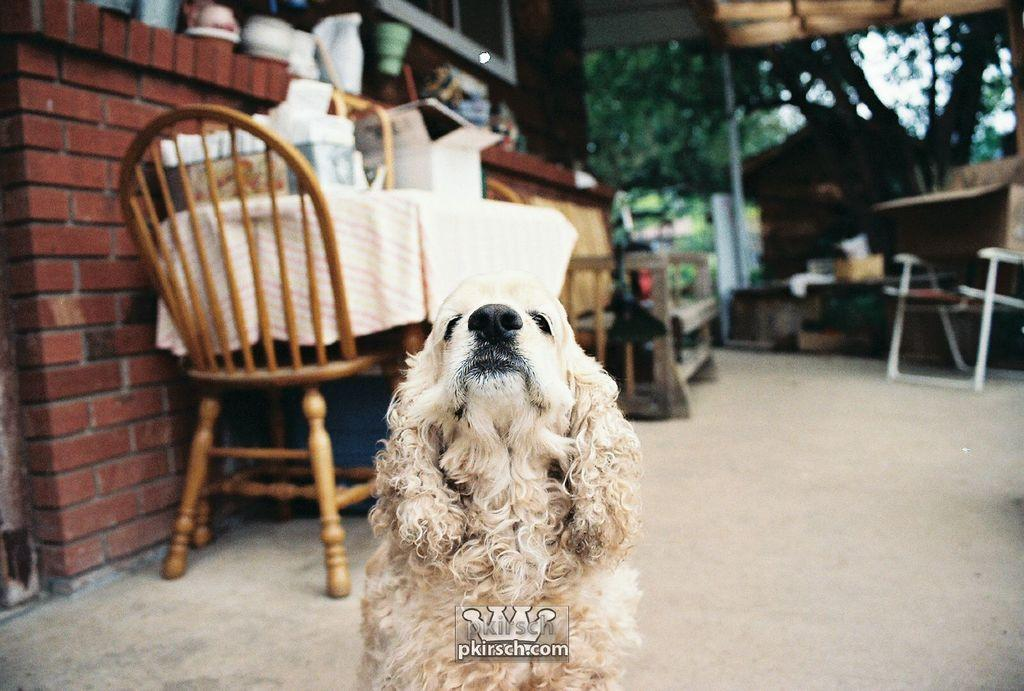What animal is on the floor in the image? There is a dog on the floor. What objects are behind the dog? There is a table and a chair behind the dog. What is on the table? There are two boxes on the table. What can be seen in the background of the image? There is a brick wall and a tree visible in the background. What type of reward is the dog receiving in the image? There is no indication in the image that the dog is receiving a reward, so it cannot be determined from the picture. 